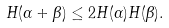<formula> <loc_0><loc_0><loc_500><loc_500>H ( \alpha + \beta ) \leq 2 H ( \alpha ) H ( \beta ) .</formula> 